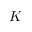<formula> <loc_0><loc_0><loc_500><loc_500>K</formula> 